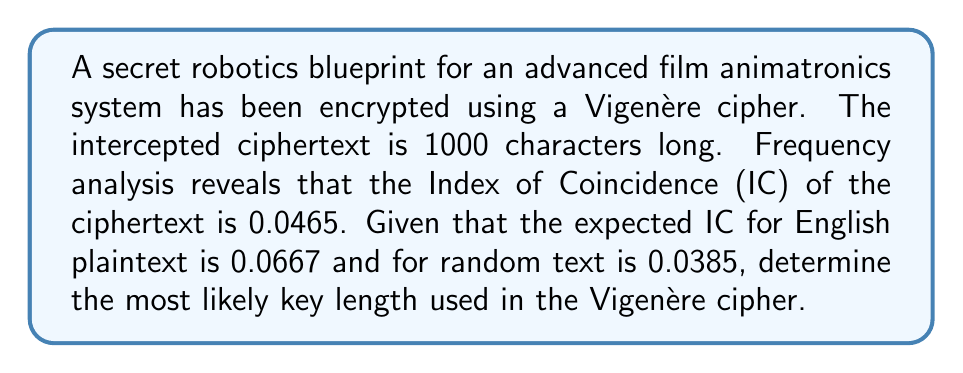Could you help me with this problem? To determine the key length of a Vigenère cipher, we can use the Index of Coincidence (IC) method. The steps are as follows:

1. Calculate the expected IC for the key length $n$ using the formula:

   $$IC_n = \frac{1}{n}(0.0667) + \frac{n-1}{n}(0.0385)$$

2. We need to find $n$ such that $IC_n$ is closest to the observed IC of 0.0465.

3. Let's try different values of $n$:

   For $n = 2$:
   $$IC_2 = \frac{1}{2}(0.0667) + \frac{1}{2}(0.0385) = 0.0526$$

   For $n = 3$:
   $$IC_3 = \frac{1}{3}(0.0667) + \frac{2}{3}(0.0385) = 0.0479$$

   For $n = 4$:
   $$IC_4 = \frac{1}{4}(0.0667) + \frac{3}{4}(0.0385) = 0.0456$$

   For $n = 5$:
   $$IC_5 = \frac{1}{5}(0.0667) + \frac{4}{5}(0.0385) = 0.0441$$

4. We see that $IC_4 = 0.0456$ is closest to the observed IC of 0.0465.

Therefore, the most likely key length is 4.
Answer: 4 